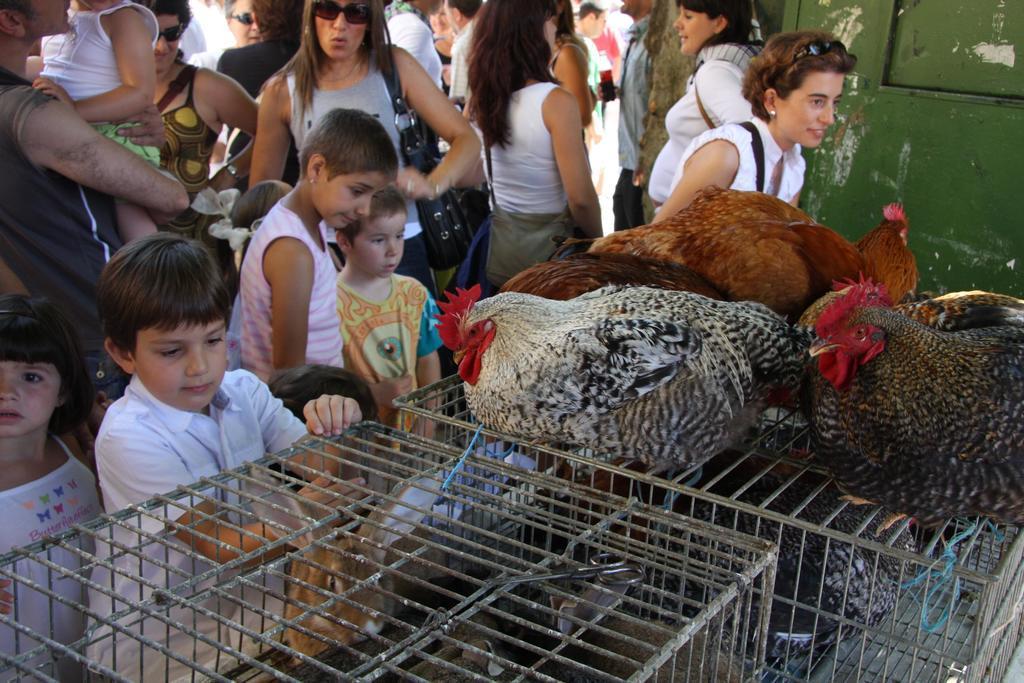In one or two sentences, can you explain what this image depicts? In this image at the bottom there are some cages, and on the cages there are some hens. And in the background there are some people standing, and also there are some children. And on the right side of the image there is one door and some of them are wearing handbags. 